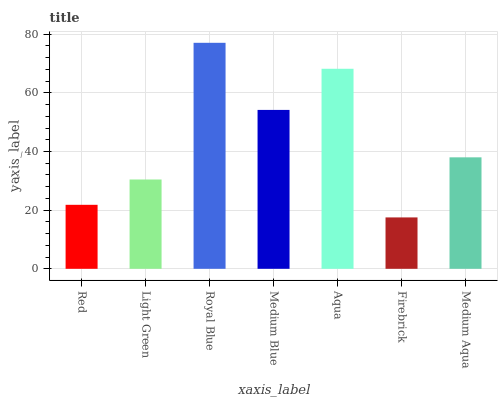Is Firebrick the minimum?
Answer yes or no. Yes. Is Royal Blue the maximum?
Answer yes or no. Yes. Is Light Green the minimum?
Answer yes or no. No. Is Light Green the maximum?
Answer yes or no. No. Is Light Green greater than Red?
Answer yes or no. Yes. Is Red less than Light Green?
Answer yes or no. Yes. Is Red greater than Light Green?
Answer yes or no. No. Is Light Green less than Red?
Answer yes or no. No. Is Medium Aqua the high median?
Answer yes or no. Yes. Is Medium Aqua the low median?
Answer yes or no. Yes. Is Medium Blue the high median?
Answer yes or no. No. Is Red the low median?
Answer yes or no. No. 